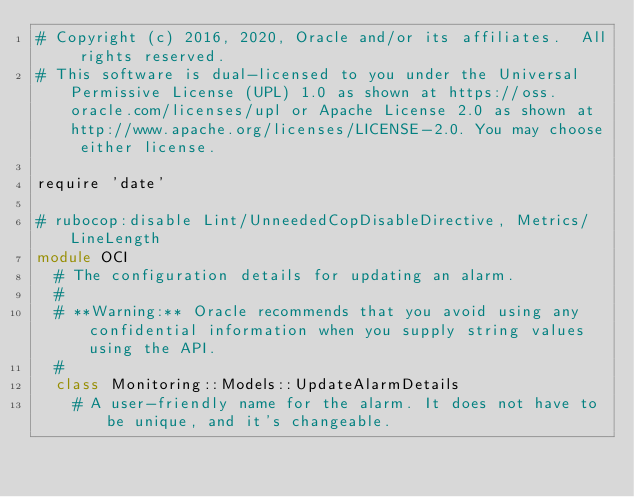<code> <loc_0><loc_0><loc_500><loc_500><_Ruby_># Copyright (c) 2016, 2020, Oracle and/or its affiliates.  All rights reserved.
# This software is dual-licensed to you under the Universal Permissive License (UPL) 1.0 as shown at https://oss.oracle.com/licenses/upl or Apache License 2.0 as shown at http://www.apache.org/licenses/LICENSE-2.0. You may choose either license.

require 'date'

# rubocop:disable Lint/UnneededCopDisableDirective, Metrics/LineLength
module OCI
  # The configuration details for updating an alarm.
  #
  # **Warning:** Oracle recommends that you avoid using any confidential information when you supply string values using the API.
  #
  class Monitoring::Models::UpdateAlarmDetails
    # A user-friendly name for the alarm. It does not have to be unique, and it's changeable.</code> 